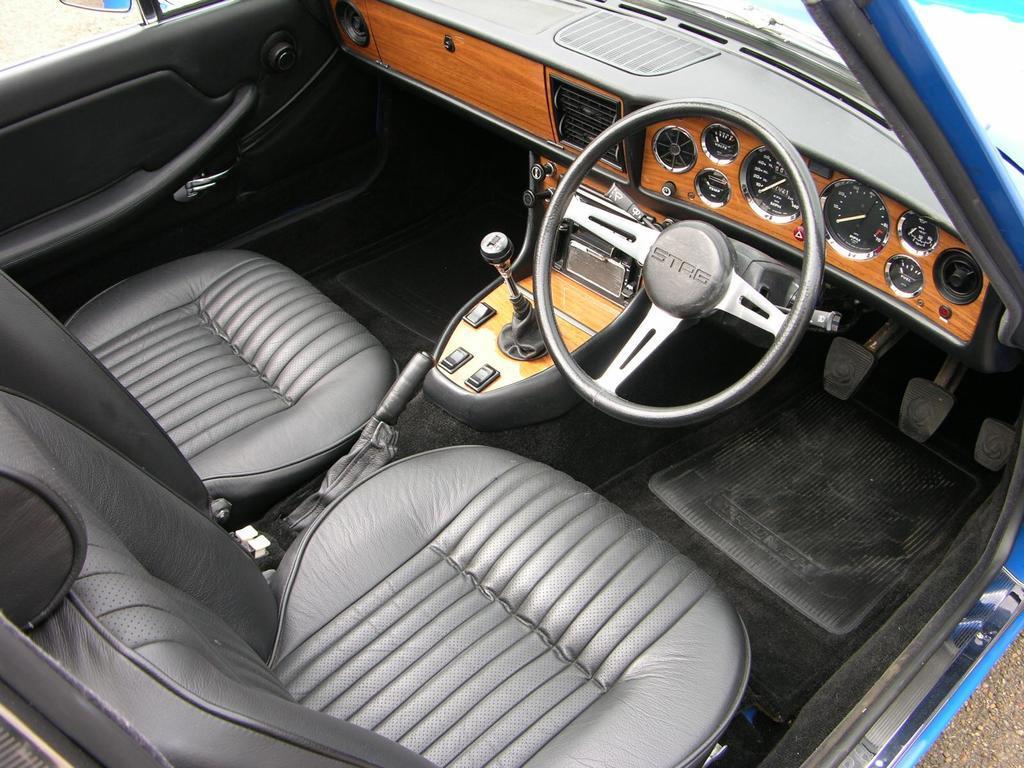Please provide a concise description of this image. This picture is clicked inside the car. Here, we see two seats, steering wheel, gear, brake and clutch. We even see the mirror and front glass. In this picture, we see some inner parts of the vehicle. 